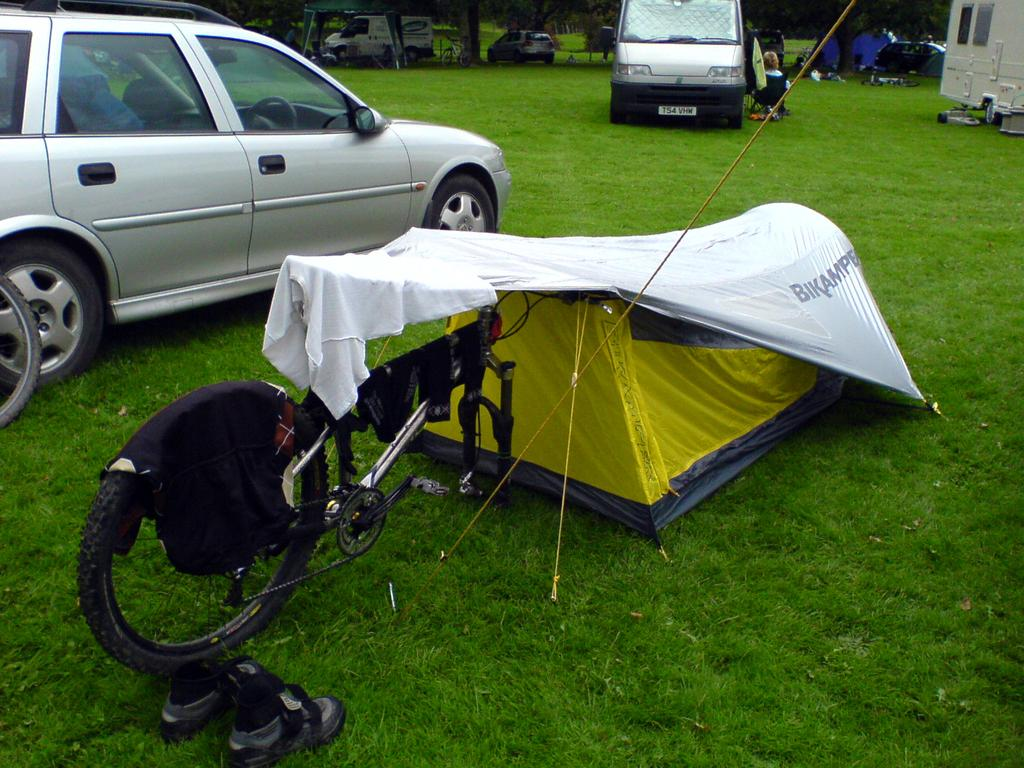What type of vehicle is present in the image? There is a bicycle in the image. What type of shelter is visible in the image? There is a tent in the image. What other vehicles can be seen in the image? There are cars in the image. What type of vegetation is present in the image? There are trees are visible in the image. What type of ground surface is at the bottom of the image? There is grass at the bottom of the image. Where are the shoes located in the image? There is a pair of shoes on the left side of the image. What type of tin can be seen in the image? There is no tin present in the image. What type of drug is being used in the image? There is no drug present in the image. 